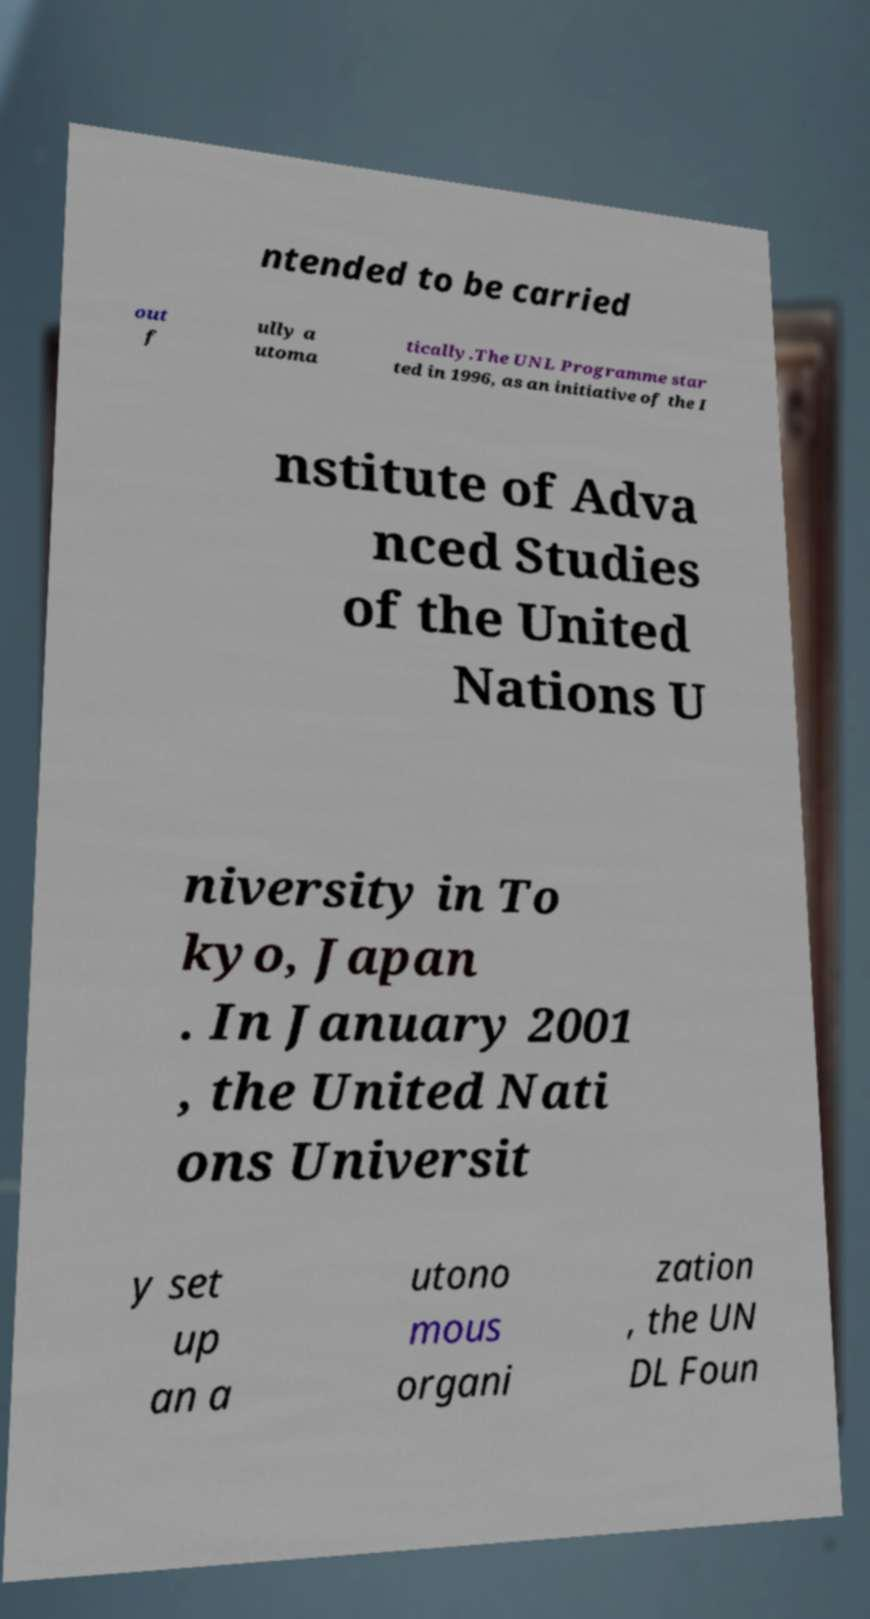What messages or text are displayed in this image? I need them in a readable, typed format. ntended to be carried out f ully a utoma tically.The UNL Programme star ted in 1996, as an initiative of the I nstitute of Adva nced Studies of the United Nations U niversity in To kyo, Japan . In January 2001 , the United Nati ons Universit y set up an a utono mous organi zation , the UN DL Foun 